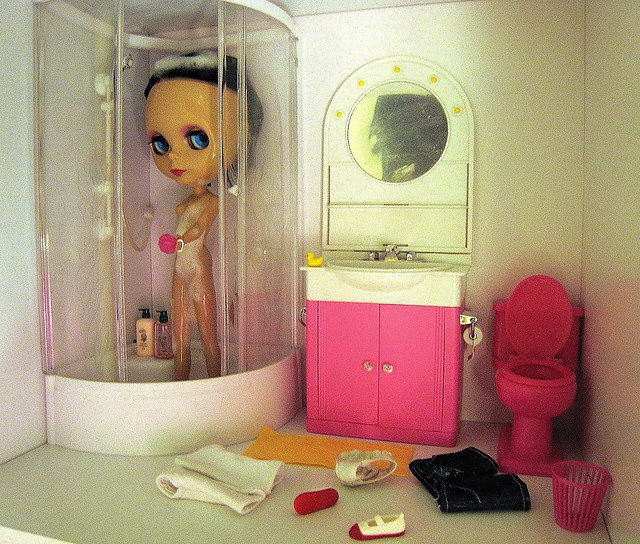Describe the objects in this image and their specific colors. I can see toilet in tan, brown, maroon, and black tones and sink in tan, khaki, and beige tones in this image. 